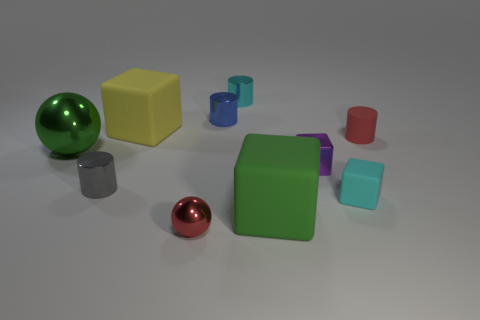Subtract all yellow cubes. How many cubes are left? 3 Subtract all small cyan cubes. How many cubes are left? 3 Subtract 0 cyan spheres. How many objects are left? 10 Subtract all cylinders. How many objects are left? 6 Subtract 1 balls. How many balls are left? 1 Subtract all cyan blocks. Subtract all green spheres. How many blocks are left? 3 Subtract all brown balls. How many gray cylinders are left? 1 Subtract all tiny metallic things. Subtract all cubes. How many objects are left? 1 Add 1 green rubber things. How many green rubber things are left? 2 Add 6 balls. How many balls exist? 8 